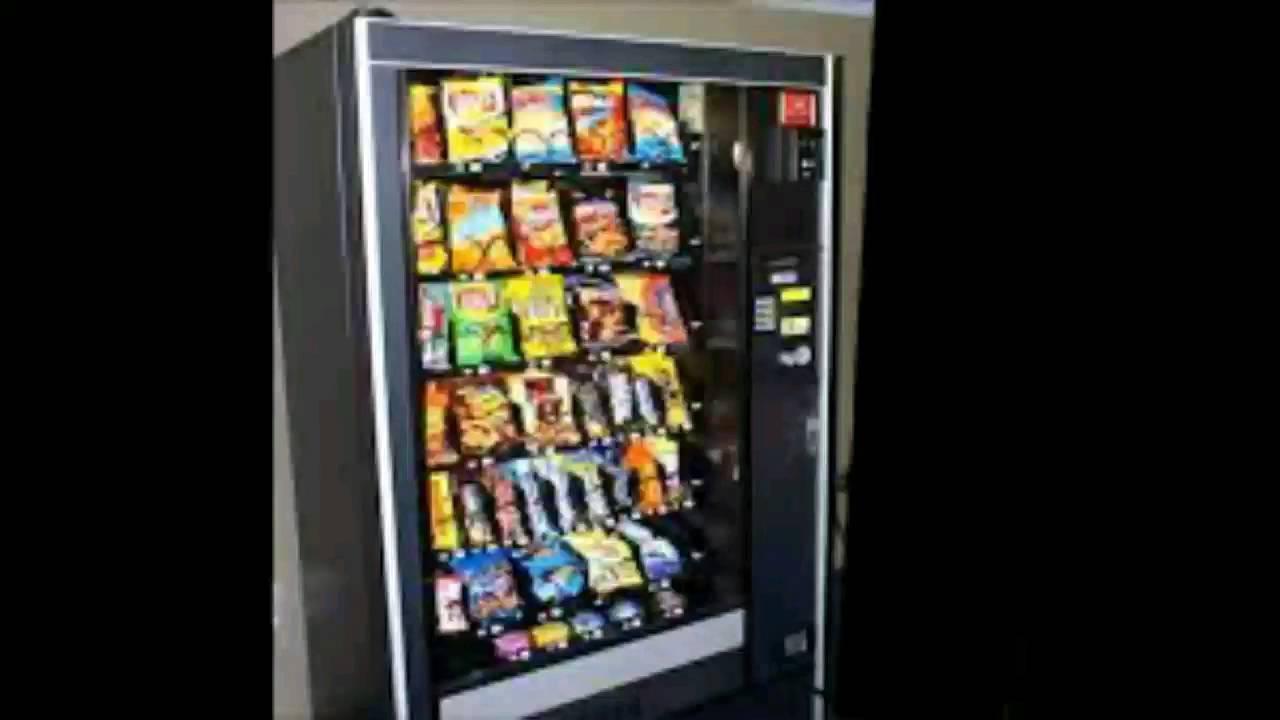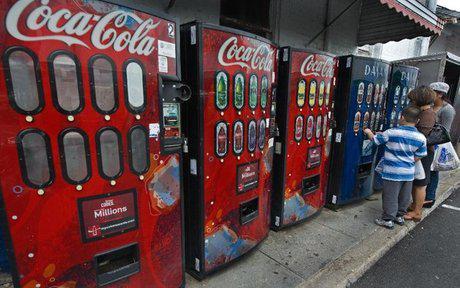The first image is the image on the left, the second image is the image on the right. For the images displayed, is the sentence "At least one image shows only beverage vending options." factually correct? Answer yes or no. Yes. 